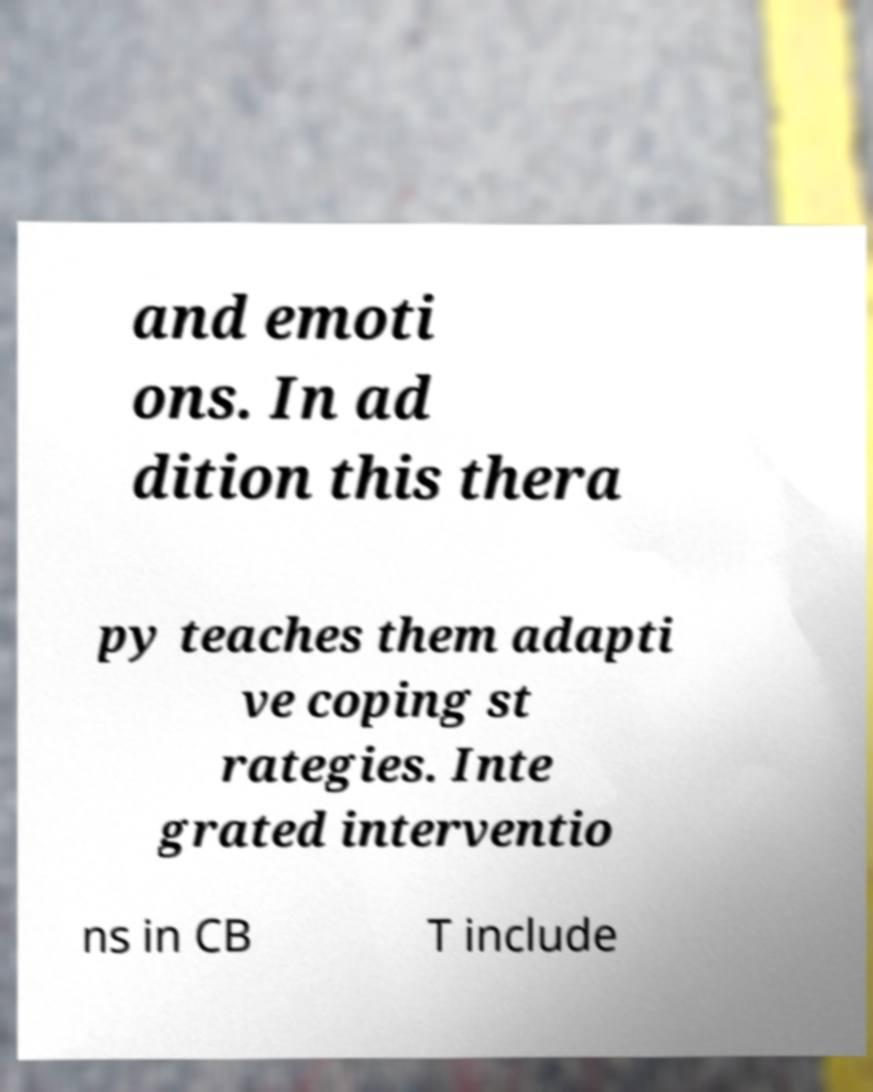Please identify and transcribe the text found in this image. and emoti ons. In ad dition this thera py teaches them adapti ve coping st rategies. Inte grated interventio ns in CB T include 